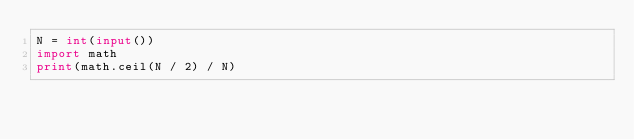Convert code to text. <code><loc_0><loc_0><loc_500><loc_500><_Python_>N = int(input())
import math
print(math.ceil(N / 2) / N)</code> 